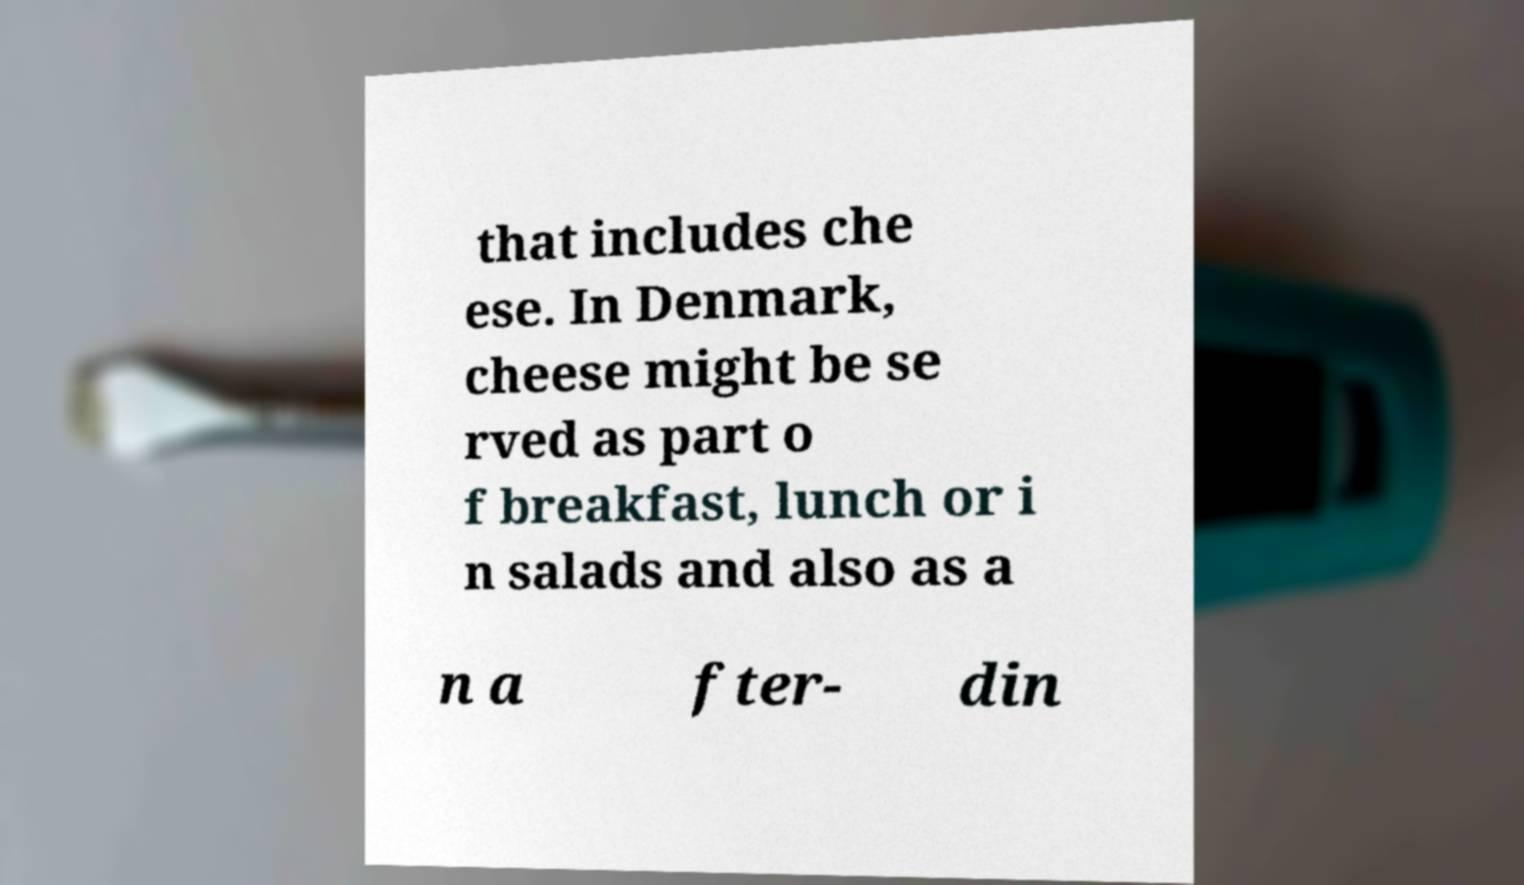There's text embedded in this image that I need extracted. Can you transcribe it verbatim? that includes che ese. In Denmark, cheese might be se rved as part o f breakfast, lunch or i n salads and also as a n a fter- din 